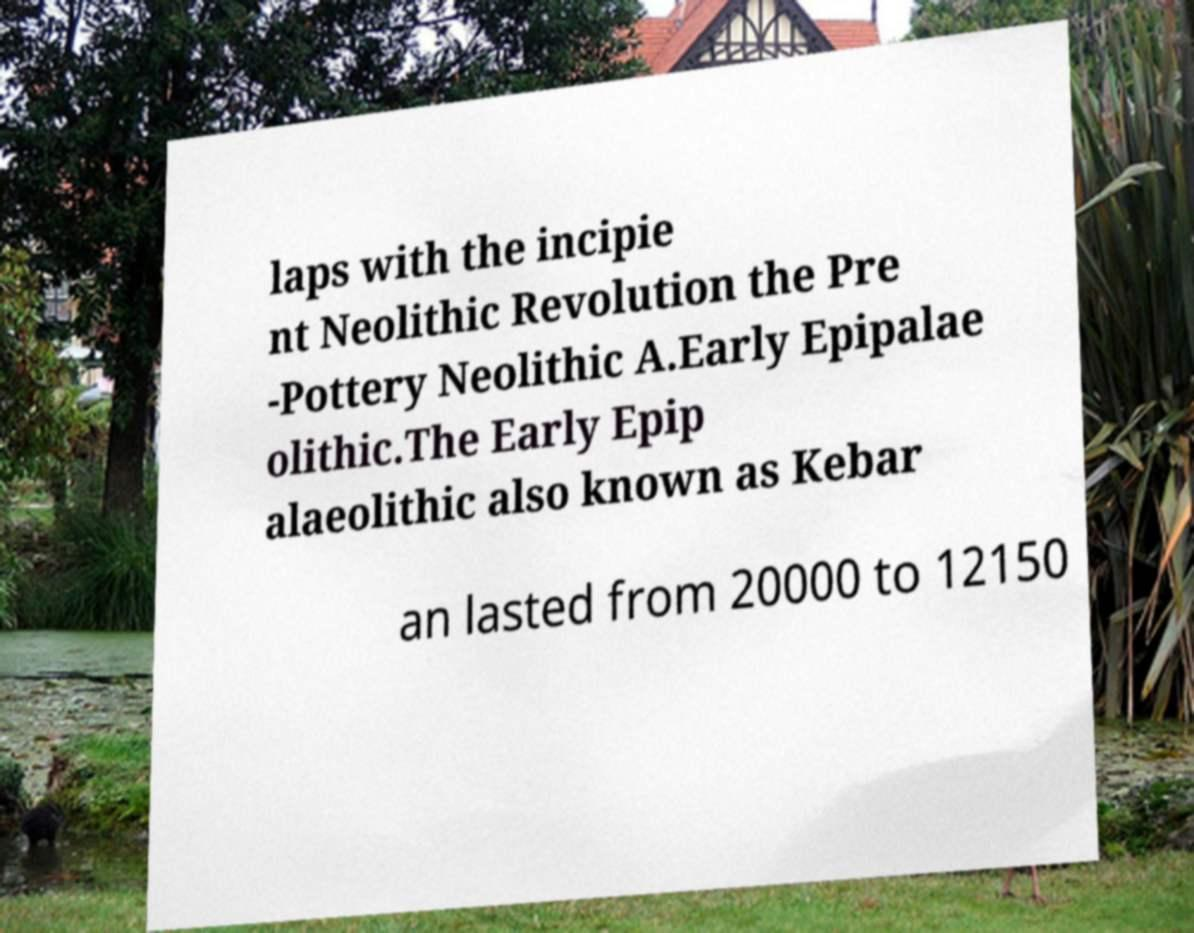Could you assist in decoding the text presented in this image and type it out clearly? laps with the incipie nt Neolithic Revolution the Pre -Pottery Neolithic A.Early Epipalae olithic.The Early Epip alaeolithic also known as Kebar an lasted from 20000 to 12150 